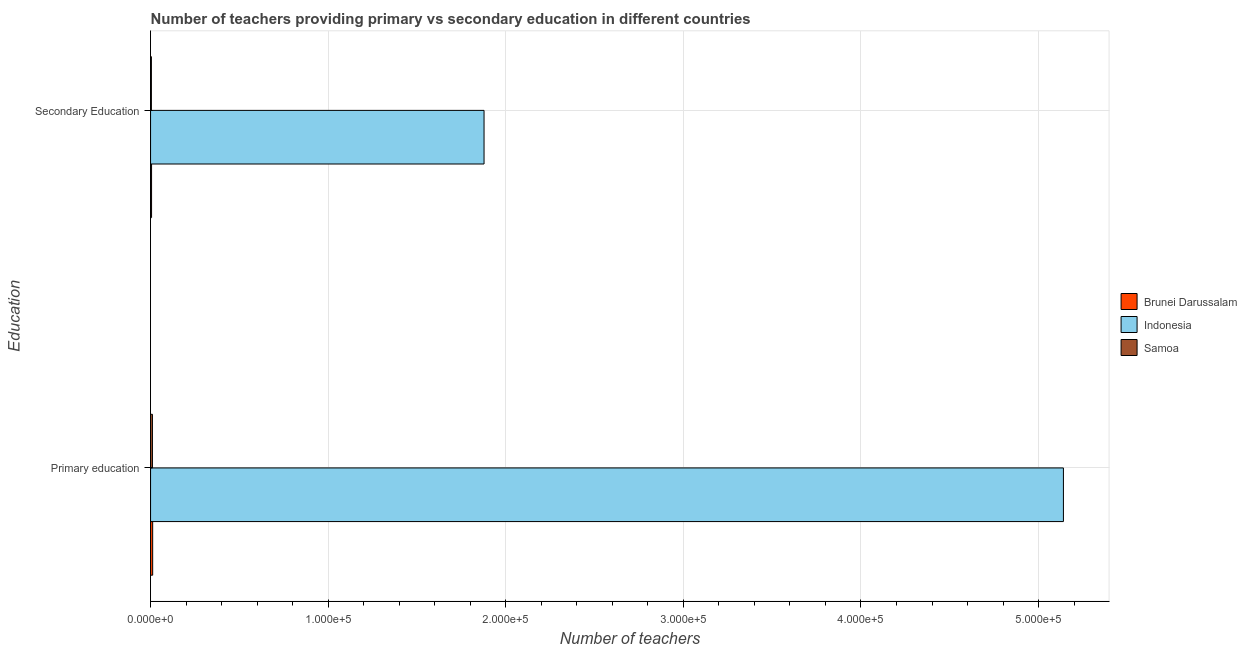How many different coloured bars are there?
Provide a succinct answer. 3. How many bars are there on the 1st tick from the top?
Offer a terse response. 3. What is the number of primary teachers in Indonesia?
Your response must be concise. 5.14e+05. Across all countries, what is the maximum number of secondary teachers?
Give a very brief answer. 1.88e+05. Across all countries, what is the minimum number of primary teachers?
Your response must be concise. 1051. In which country was the number of primary teachers maximum?
Keep it short and to the point. Indonesia. In which country was the number of primary teachers minimum?
Give a very brief answer. Samoa. What is the total number of primary teachers in the graph?
Give a very brief answer. 5.16e+05. What is the difference between the number of primary teachers in Samoa and that in Indonesia?
Keep it short and to the point. -5.13e+05. What is the difference between the number of secondary teachers in Indonesia and the number of primary teachers in Samoa?
Ensure brevity in your answer.  1.87e+05. What is the average number of secondary teachers per country?
Your answer should be very brief. 6.29e+04. What is the difference between the number of secondary teachers and number of primary teachers in Indonesia?
Your response must be concise. -3.26e+05. What is the ratio of the number of secondary teachers in Brunei Darussalam to that in Samoa?
Make the answer very short. 1.23. Is the number of primary teachers in Indonesia less than that in Brunei Darussalam?
Give a very brief answer. No. What does the 1st bar from the top in Secondary Education represents?
Give a very brief answer. Samoa. What does the 1st bar from the bottom in Secondary Education represents?
Give a very brief answer. Brunei Darussalam. Does the graph contain any zero values?
Your answer should be very brief. No. Where does the legend appear in the graph?
Make the answer very short. Center right. How are the legend labels stacked?
Provide a succinct answer. Vertical. What is the title of the graph?
Keep it short and to the point. Number of teachers providing primary vs secondary education in different countries. Does "Luxembourg" appear as one of the legend labels in the graph?
Your response must be concise. No. What is the label or title of the X-axis?
Provide a succinct answer. Number of teachers. What is the label or title of the Y-axis?
Provide a succinct answer. Education. What is the Number of teachers in Brunei Darussalam in Primary education?
Ensure brevity in your answer.  1190. What is the Number of teachers in Indonesia in Primary education?
Offer a terse response. 5.14e+05. What is the Number of teachers of Samoa in Primary education?
Offer a terse response. 1051. What is the Number of teachers of Brunei Darussalam in Secondary Education?
Your answer should be very brief. 565. What is the Number of teachers of Indonesia in Secondary Education?
Offer a terse response. 1.88e+05. What is the Number of teachers in Samoa in Secondary Education?
Provide a succinct answer. 460. Across all Education, what is the maximum Number of teachers in Brunei Darussalam?
Make the answer very short. 1190. Across all Education, what is the maximum Number of teachers in Indonesia?
Ensure brevity in your answer.  5.14e+05. Across all Education, what is the maximum Number of teachers of Samoa?
Your response must be concise. 1051. Across all Education, what is the minimum Number of teachers in Brunei Darussalam?
Provide a short and direct response. 565. Across all Education, what is the minimum Number of teachers of Indonesia?
Provide a succinct answer. 1.88e+05. Across all Education, what is the minimum Number of teachers in Samoa?
Your answer should be compact. 460. What is the total Number of teachers of Brunei Darussalam in the graph?
Offer a very short reply. 1755. What is the total Number of teachers in Indonesia in the graph?
Your answer should be compact. 7.02e+05. What is the total Number of teachers of Samoa in the graph?
Your response must be concise. 1511. What is the difference between the Number of teachers in Brunei Darussalam in Primary education and that in Secondary Education?
Provide a succinct answer. 625. What is the difference between the Number of teachers of Indonesia in Primary education and that in Secondary Education?
Offer a terse response. 3.26e+05. What is the difference between the Number of teachers of Samoa in Primary education and that in Secondary Education?
Make the answer very short. 591. What is the difference between the Number of teachers in Brunei Darussalam in Primary education and the Number of teachers in Indonesia in Secondary Education?
Your answer should be compact. -1.87e+05. What is the difference between the Number of teachers in Brunei Darussalam in Primary education and the Number of teachers in Samoa in Secondary Education?
Your response must be concise. 730. What is the difference between the Number of teachers in Indonesia in Primary education and the Number of teachers in Samoa in Secondary Education?
Make the answer very short. 5.14e+05. What is the average Number of teachers in Brunei Darussalam per Education?
Provide a succinct answer. 877.5. What is the average Number of teachers of Indonesia per Education?
Your answer should be very brief. 3.51e+05. What is the average Number of teachers of Samoa per Education?
Your answer should be very brief. 755.5. What is the difference between the Number of teachers of Brunei Darussalam and Number of teachers of Indonesia in Primary education?
Ensure brevity in your answer.  -5.13e+05. What is the difference between the Number of teachers in Brunei Darussalam and Number of teachers in Samoa in Primary education?
Give a very brief answer. 139. What is the difference between the Number of teachers in Indonesia and Number of teachers in Samoa in Primary education?
Keep it short and to the point. 5.13e+05. What is the difference between the Number of teachers of Brunei Darussalam and Number of teachers of Indonesia in Secondary Education?
Your answer should be compact. -1.87e+05. What is the difference between the Number of teachers in Brunei Darussalam and Number of teachers in Samoa in Secondary Education?
Offer a very short reply. 105. What is the difference between the Number of teachers of Indonesia and Number of teachers of Samoa in Secondary Education?
Your answer should be compact. 1.87e+05. What is the ratio of the Number of teachers in Brunei Darussalam in Primary education to that in Secondary Education?
Provide a succinct answer. 2.11. What is the ratio of the Number of teachers of Indonesia in Primary education to that in Secondary Education?
Provide a succinct answer. 2.74. What is the ratio of the Number of teachers in Samoa in Primary education to that in Secondary Education?
Offer a very short reply. 2.28. What is the difference between the highest and the second highest Number of teachers of Brunei Darussalam?
Offer a terse response. 625. What is the difference between the highest and the second highest Number of teachers of Indonesia?
Your response must be concise. 3.26e+05. What is the difference between the highest and the second highest Number of teachers in Samoa?
Provide a short and direct response. 591. What is the difference between the highest and the lowest Number of teachers of Brunei Darussalam?
Ensure brevity in your answer.  625. What is the difference between the highest and the lowest Number of teachers in Indonesia?
Offer a terse response. 3.26e+05. What is the difference between the highest and the lowest Number of teachers of Samoa?
Ensure brevity in your answer.  591. 